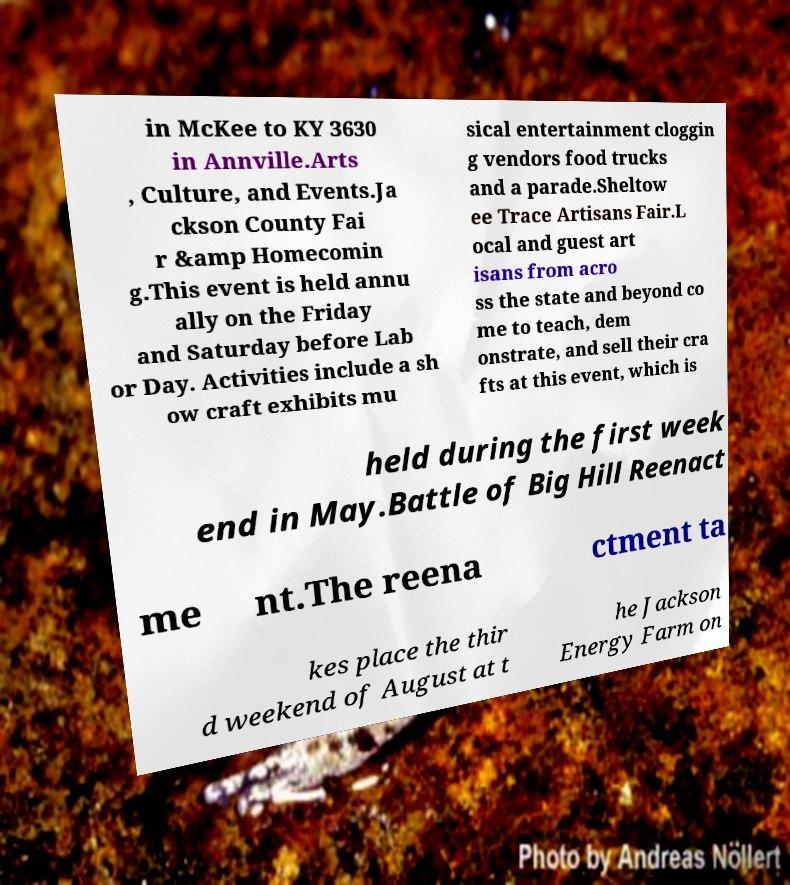For documentation purposes, I need the text within this image transcribed. Could you provide that? in McKee to KY 3630 in Annville.Arts , Culture, and Events.Ja ckson County Fai r &amp Homecomin g.This event is held annu ally on the Friday and Saturday before Lab or Day. Activities include a sh ow craft exhibits mu sical entertainment cloggin g vendors food trucks and a parade.Sheltow ee Trace Artisans Fair.L ocal and guest art isans from acro ss the state and beyond co me to teach, dem onstrate, and sell their cra fts at this event, which is held during the first week end in May.Battle of Big Hill Reenact me nt.The reena ctment ta kes place the thir d weekend of August at t he Jackson Energy Farm on 